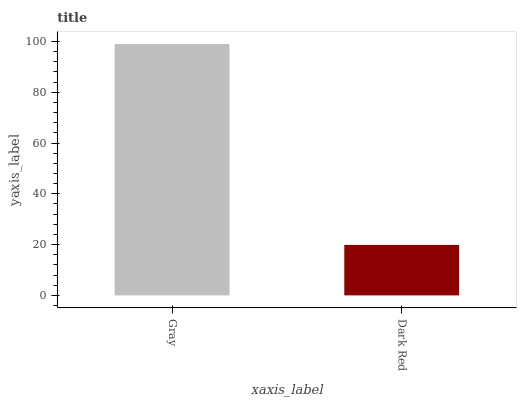Is Dark Red the minimum?
Answer yes or no. Yes. Is Gray the maximum?
Answer yes or no. Yes. Is Dark Red the maximum?
Answer yes or no. No. Is Gray greater than Dark Red?
Answer yes or no. Yes. Is Dark Red less than Gray?
Answer yes or no. Yes. Is Dark Red greater than Gray?
Answer yes or no. No. Is Gray less than Dark Red?
Answer yes or no. No. Is Gray the high median?
Answer yes or no. Yes. Is Dark Red the low median?
Answer yes or no. Yes. Is Dark Red the high median?
Answer yes or no. No. Is Gray the low median?
Answer yes or no. No. 